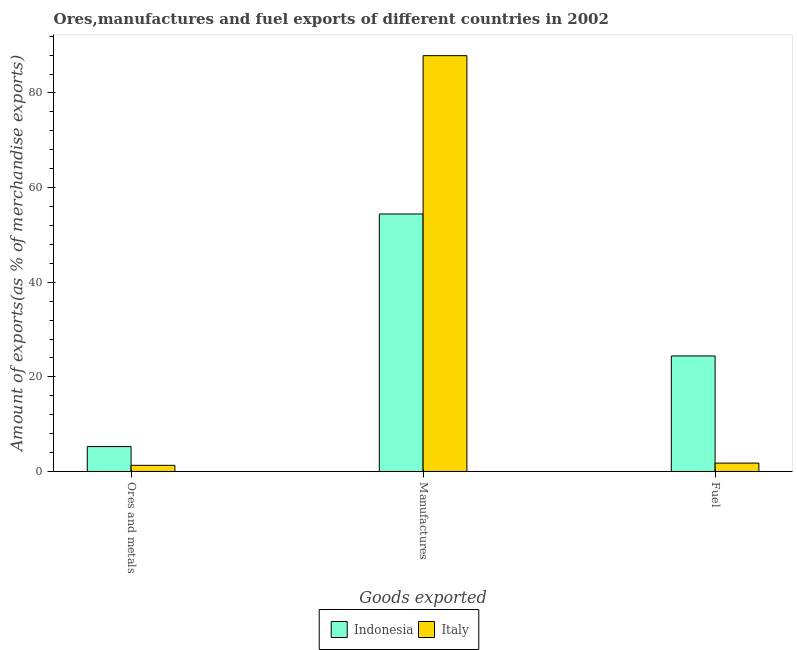How many different coloured bars are there?
Your answer should be very brief. 2. Are the number of bars per tick equal to the number of legend labels?
Keep it short and to the point. Yes. Are the number of bars on each tick of the X-axis equal?
Give a very brief answer. Yes. How many bars are there on the 2nd tick from the right?
Give a very brief answer. 2. What is the label of the 3rd group of bars from the left?
Make the answer very short. Fuel. What is the percentage of fuel exports in Italy?
Keep it short and to the point. 1.77. Across all countries, what is the maximum percentage of ores and metals exports?
Your answer should be compact. 5.26. Across all countries, what is the minimum percentage of fuel exports?
Your answer should be very brief. 1.77. In which country was the percentage of manufactures exports minimum?
Your response must be concise. Indonesia. What is the total percentage of ores and metals exports in the graph?
Offer a very short reply. 6.57. What is the difference between the percentage of ores and metals exports in Indonesia and that in Italy?
Make the answer very short. 3.96. What is the difference between the percentage of fuel exports in Italy and the percentage of manufactures exports in Indonesia?
Provide a short and direct response. -52.66. What is the average percentage of ores and metals exports per country?
Offer a terse response. 3.28. What is the difference between the percentage of ores and metals exports and percentage of fuel exports in Italy?
Your answer should be very brief. -0.47. In how many countries, is the percentage of fuel exports greater than 8 %?
Your answer should be compact. 1. What is the ratio of the percentage of manufactures exports in Indonesia to that in Italy?
Your answer should be very brief. 0.62. What is the difference between the highest and the second highest percentage of fuel exports?
Keep it short and to the point. 22.65. What is the difference between the highest and the lowest percentage of manufactures exports?
Offer a very short reply. 33.46. Is the sum of the percentage of manufactures exports in Italy and Indonesia greater than the maximum percentage of fuel exports across all countries?
Make the answer very short. Yes. What does the 1st bar from the right in Manufactures represents?
Ensure brevity in your answer.  Italy. Is it the case that in every country, the sum of the percentage of ores and metals exports and percentage of manufactures exports is greater than the percentage of fuel exports?
Ensure brevity in your answer.  Yes. How many bars are there?
Your answer should be very brief. 6. Are all the bars in the graph horizontal?
Your answer should be very brief. No. How many countries are there in the graph?
Offer a terse response. 2. Are the values on the major ticks of Y-axis written in scientific E-notation?
Provide a short and direct response. No. Does the graph contain any zero values?
Make the answer very short. No. Where does the legend appear in the graph?
Offer a very short reply. Bottom center. How are the legend labels stacked?
Make the answer very short. Horizontal. What is the title of the graph?
Offer a terse response. Ores,manufactures and fuel exports of different countries in 2002. What is the label or title of the X-axis?
Keep it short and to the point. Goods exported. What is the label or title of the Y-axis?
Your response must be concise. Amount of exports(as % of merchandise exports). What is the Amount of exports(as % of merchandise exports) of Indonesia in Ores and metals?
Keep it short and to the point. 5.26. What is the Amount of exports(as % of merchandise exports) of Italy in Ores and metals?
Give a very brief answer. 1.3. What is the Amount of exports(as % of merchandise exports) of Indonesia in Manufactures?
Ensure brevity in your answer.  54.43. What is the Amount of exports(as % of merchandise exports) of Italy in Manufactures?
Make the answer very short. 87.89. What is the Amount of exports(as % of merchandise exports) in Indonesia in Fuel?
Provide a short and direct response. 24.42. What is the Amount of exports(as % of merchandise exports) in Italy in Fuel?
Your response must be concise. 1.77. Across all Goods exported, what is the maximum Amount of exports(as % of merchandise exports) of Indonesia?
Your answer should be very brief. 54.43. Across all Goods exported, what is the maximum Amount of exports(as % of merchandise exports) in Italy?
Keep it short and to the point. 87.89. Across all Goods exported, what is the minimum Amount of exports(as % of merchandise exports) in Indonesia?
Your answer should be very brief. 5.26. Across all Goods exported, what is the minimum Amount of exports(as % of merchandise exports) of Italy?
Give a very brief answer. 1.3. What is the total Amount of exports(as % of merchandise exports) of Indonesia in the graph?
Provide a short and direct response. 84.11. What is the total Amount of exports(as % of merchandise exports) of Italy in the graph?
Keep it short and to the point. 90.96. What is the difference between the Amount of exports(as % of merchandise exports) of Indonesia in Ores and metals and that in Manufactures?
Ensure brevity in your answer.  -49.16. What is the difference between the Amount of exports(as % of merchandise exports) of Italy in Ores and metals and that in Manufactures?
Ensure brevity in your answer.  -86.59. What is the difference between the Amount of exports(as % of merchandise exports) of Indonesia in Ores and metals and that in Fuel?
Your response must be concise. -19.16. What is the difference between the Amount of exports(as % of merchandise exports) of Italy in Ores and metals and that in Fuel?
Make the answer very short. -0.47. What is the difference between the Amount of exports(as % of merchandise exports) of Indonesia in Manufactures and that in Fuel?
Ensure brevity in your answer.  30.01. What is the difference between the Amount of exports(as % of merchandise exports) in Italy in Manufactures and that in Fuel?
Provide a short and direct response. 86.12. What is the difference between the Amount of exports(as % of merchandise exports) of Indonesia in Ores and metals and the Amount of exports(as % of merchandise exports) of Italy in Manufactures?
Your answer should be very brief. -82.63. What is the difference between the Amount of exports(as % of merchandise exports) of Indonesia in Ores and metals and the Amount of exports(as % of merchandise exports) of Italy in Fuel?
Your answer should be compact. 3.49. What is the difference between the Amount of exports(as % of merchandise exports) in Indonesia in Manufactures and the Amount of exports(as % of merchandise exports) in Italy in Fuel?
Your answer should be compact. 52.66. What is the average Amount of exports(as % of merchandise exports) in Indonesia per Goods exported?
Give a very brief answer. 28.04. What is the average Amount of exports(as % of merchandise exports) in Italy per Goods exported?
Provide a short and direct response. 30.32. What is the difference between the Amount of exports(as % of merchandise exports) of Indonesia and Amount of exports(as % of merchandise exports) of Italy in Ores and metals?
Keep it short and to the point. 3.96. What is the difference between the Amount of exports(as % of merchandise exports) of Indonesia and Amount of exports(as % of merchandise exports) of Italy in Manufactures?
Provide a succinct answer. -33.46. What is the difference between the Amount of exports(as % of merchandise exports) of Indonesia and Amount of exports(as % of merchandise exports) of Italy in Fuel?
Your answer should be compact. 22.65. What is the ratio of the Amount of exports(as % of merchandise exports) in Indonesia in Ores and metals to that in Manufactures?
Give a very brief answer. 0.1. What is the ratio of the Amount of exports(as % of merchandise exports) of Italy in Ores and metals to that in Manufactures?
Your answer should be very brief. 0.01. What is the ratio of the Amount of exports(as % of merchandise exports) of Indonesia in Ores and metals to that in Fuel?
Your answer should be very brief. 0.22. What is the ratio of the Amount of exports(as % of merchandise exports) in Italy in Ores and metals to that in Fuel?
Make the answer very short. 0.74. What is the ratio of the Amount of exports(as % of merchandise exports) in Indonesia in Manufactures to that in Fuel?
Offer a very short reply. 2.23. What is the ratio of the Amount of exports(as % of merchandise exports) of Italy in Manufactures to that in Fuel?
Your answer should be compact. 49.64. What is the difference between the highest and the second highest Amount of exports(as % of merchandise exports) of Indonesia?
Make the answer very short. 30.01. What is the difference between the highest and the second highest Amount of exports(as % of merchandise exports) in Italy?
Offer a terse response. 86.12. What is the difference between the highest and the lowest Amount of exports(as % of merchandise exports) in Indonesia?
Keep it short and to the point. 49.16. What is the difference between the highest and the lowest Amount of exports(as % of merchandise exports) of Italy?
Your response must be concise. 86.59. 